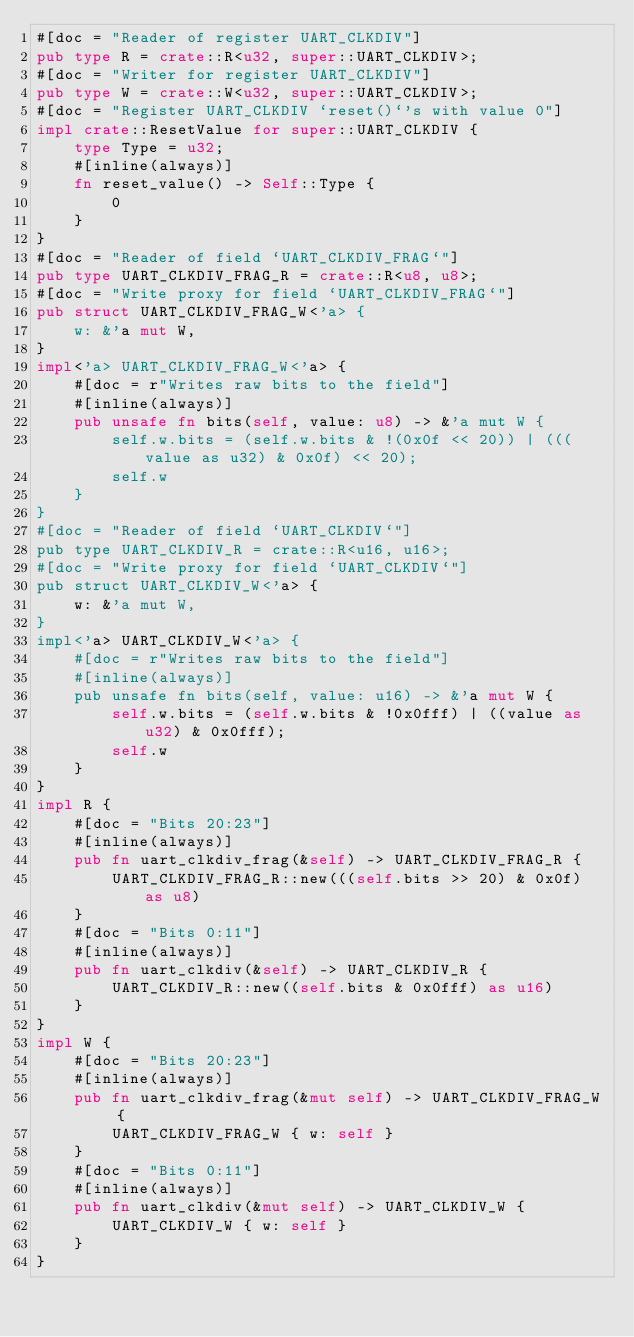Convert code to text. <code><loc_0><loc_0><loc_500><loc_500><_Rust_>#[doc = "Reader of register UART_CLKDIV"]
pub type R = crate::R<u32, super::UART_CLKDIV>;
#[doc = "Writer for register UART_CLKDIV"]
pub type W = crate::W<u32, super::UART_CLKDIV>;
#[doc = "Register UART_CLKDIV `reset()`'s with value 0"]
impl crate::ResetValue for super::UART_CLKDIV {
    type Type = u32;
    #[inline(always)]
    fn reset_value() -> Self::Type {
        0
    }
}
#[doc = "Reader of field `UART_CLKDIV_FRAG`"]
pub type UART_CLKDIV_FRAG_R = crate::R<u8, u8>;
#[doc = "Write proxy for field `UART_CLKDIV_FRAG`"]
pub struct UART_CLKDIV_FRAG_W<'a> {
    w: &'a mut W,
}
impl<'a> UART_CLKDIV_FRAG_W<'a> {
    #[doc = r"Writes raw bits to the field"]
    #[inline(always)]
    pub unsafe fn bits(self, value: u8) -> &'a mut W {
        self.w.bits = (self.w.bits & !(0x0f << 20)) | (((value as u32) & 0x0f) << 20);
        self.w
    }
}
#[doc = "Reader of field `UART_CLKDIV`"]
pub type UART_CLKDIV_R = crate::R<u16, u16>;
#[doc = "Write proxy for field `UART_CLKDIV`"]
pub struct UART_CLKDIV_W<'a> {
    w: &'a mut W,
}
impl<'a> UART_CLKDIV_W<'a> {
    #[doc = r"Writes raw bits to the field"]
    #[inline(always)]
    pub unsafe fn bits(self, value: u16) -> &'a mut W {
        self.w.bits = (self.w.bits & !0x0fff) | ((value as u32) & 0x0fff);
        self.w
    }
}
impl R {
    #[doc = "Bits 20:23"]
    #[inline(always)]
    pub fn uart_clkdiv_frag(&self) -> UART_CLKDIV_FRAG_R {
        UART_CLKDIV_FRAG_R::new(((self.bits >> 20) & 0x0f) as u8)
    }
    #[doc = "Bits 0:11"]
    #[inline(always)]
    pub fn uart_clkdiv(&self) -> UART_CLKDIV_R {
        UART_CLKDIV_R::new((self.bits & 0x0fff) as u16)
    }
}
impl W {
    #[doc = "Bits 20:23"]
    #[inline(always)]
    pub fn uart_clkdiv_frag(&mut self) -> UART_CLKDIV_FRAG_W {
        UART_CLKDIV_FRAG_W { w: self }
    }
    #[doc = "Bits 0:11"]
    #[inline(always)]
    pub fn uart_clkdiv(&mut self) -> UART_CLKDIV_W {
        UART_CLKDIV_W { w: self }
    }
}
</code> 